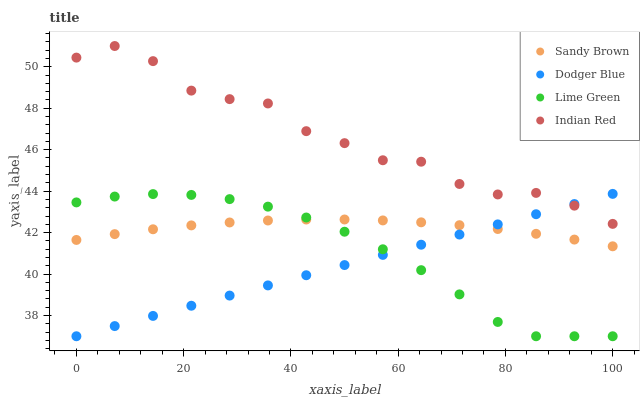Does Dodger Blue have the minimum area under the curve?
Answer yes or no. Yes. Does Indian Red have the maximum area under the curve?
Answer yes or no. Yes. Does Sandy Brown have the minimum area under the curve?
Answer yes or no. No. Does Sandy Brown have the maximum area under the curve?
Answer yes or no. No. Is Dodger Blue the smoothest?
Answer yes or no. Yes. Is Indian Red the roughest?
Answer yes or no. Yes. Is Sandy Brown the smoothest?
Answer yes or no. No. Is Sandy Brown the roughest?
Answer yes or no. No. Does Dodger Blue have the lowest value?
Answer yes or no. Yes. Does Sandy Brown have the lowest value?
Answer yes or no. No. Does Indian Red have the highest value?
Answer yes or no. Yes. Does Sandy Brown have the highest value?
Answer yes or no. No. Is Lime Green less than Indian Red?
Answer yes or no. Yes. Is Indian Red greater than Sandy Brown?
Answer yes or no. Yes. Does Sandy Brown intersect Lime Green?
Answer yes or no. Yes. Is Sandy Brown less than Lime Green?
Answer yes or no. No. Is Sandy Brown greater than Lime Green?
Answer yes or no. No. Does Lime Green intersect Indian Red?
Answer yes or no. No. 